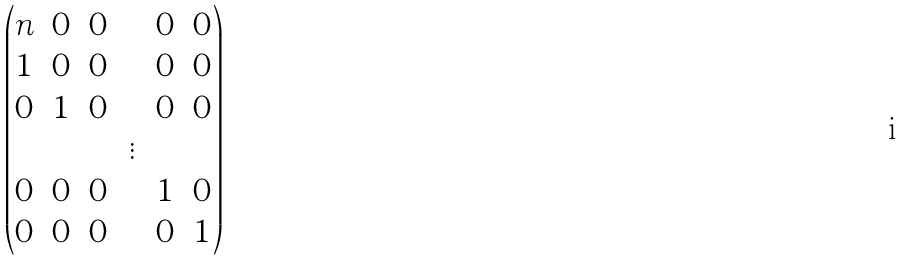<formula> <loc_0><loc_0><loc_500><loc_500>\begin{pmatrix} n & 0 & 0 & \cdots & 0 & 0 \\ 1 & 0 & 0 & \cdots & 0 & 0 \\ 0 & 1 & 0 & \cdots & 0 & 0 \\ & & & \vdots \\ 0 & 0 & 0 & \cdots & 1 & 0 \\ 0 & 0 & 0 & \cdots & 0 & 1 \end{pmatrix}</formula> 